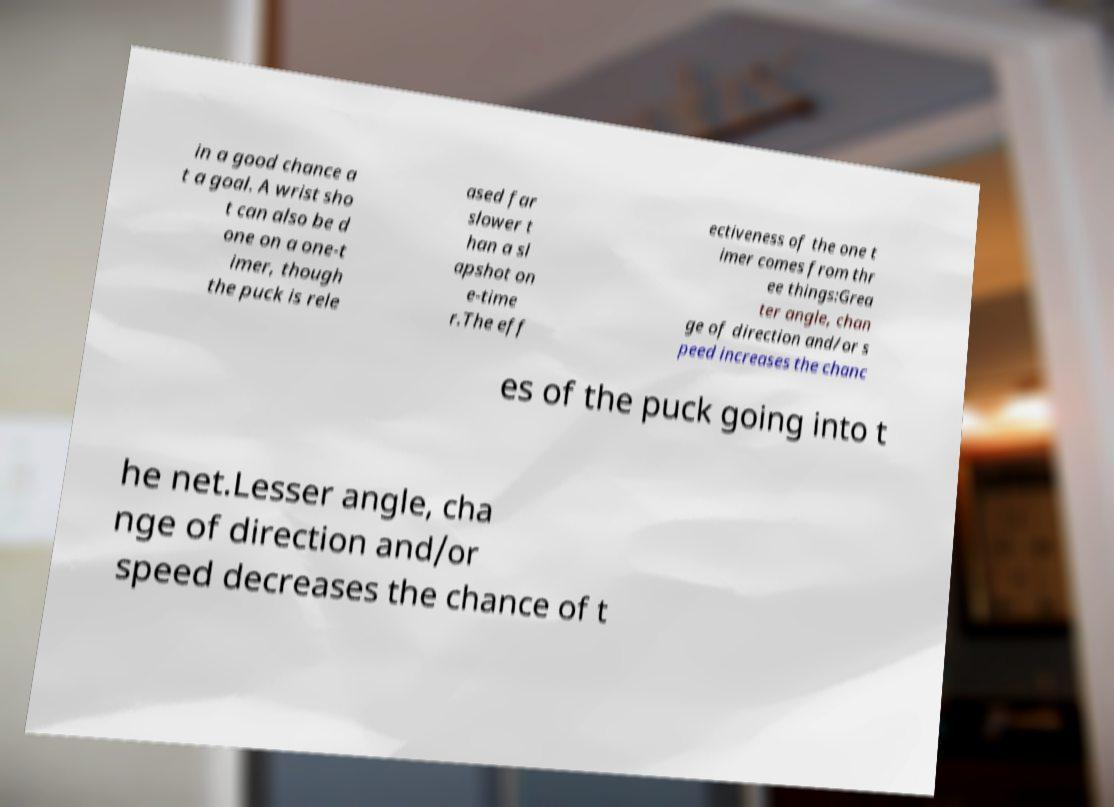I need the written content from this picture converted into text. Can you do that? in a good chance a t a goal. A wrist sho t can also be d one on a one-t imer, though the puck is rele ased far slower t han a sl apshot on e-time r.The eff ectiveness of the one t imer comes from thr ee things:Grea ter angle, chan ge of direction and/or s peed increases the chanc es of the puck going into t he net.Lesser angle, cha nge of direction and/or speed decreases the chance of t 